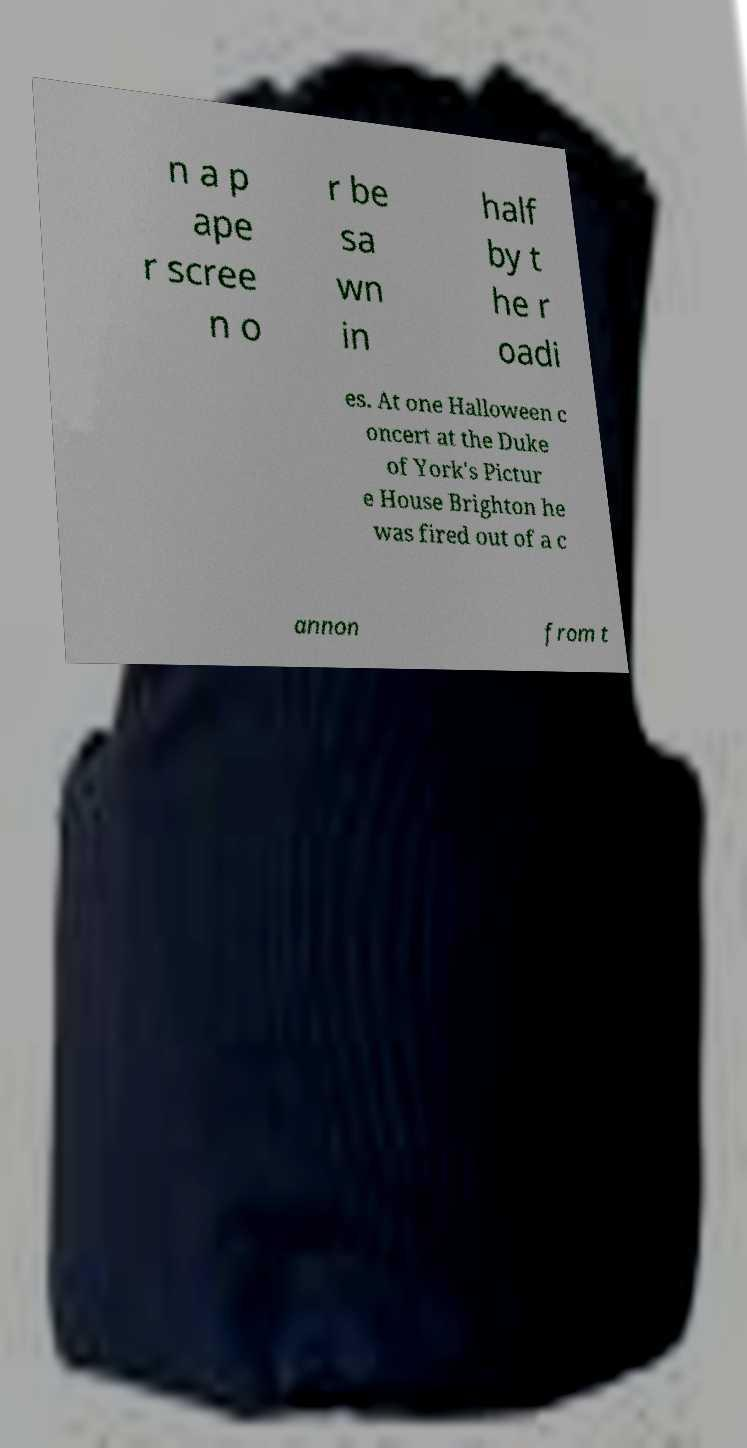Please read and relay the text visible in this image. What does it say? n a p ape r scree n o r be sa wn in half by t he r oadi es. At one Halloween c oncert at the Duke of York's Pictur e House Brighton he was fired out of a c annon from t 